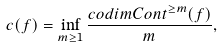Convert formula to latex. <formula><loc_0><loc_0><loc_500><loc_500>c ( f ) = \inf _ { m \geq 1 } \frac { c o d i m C o n t ^ { \geq m } ( f ) } { m } ,</formula> 